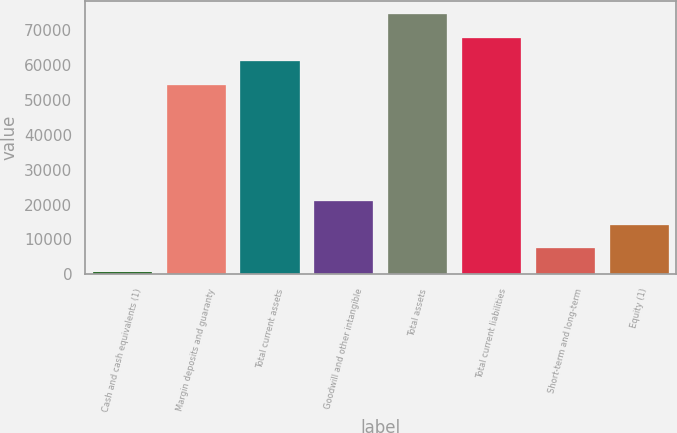Convert chart to OTSL. <chart><loc_0><loc_0><loc_500><loc_500><bar_chart><fcel>Cash and cash equivalents (1)<fcel>Margin deposits and guaranty<fcel>Total current assets<fcel>Goodwill and other intangible<fcel>Total assets<fcel>Total current liabilities<fcel>Short-term and long-term<fcel>Equity (1)<nl><fcel>652<fcel>54218.2<fcel>60978.4<fcel>20932.6<fcel>74498.8<fcel>67738.6<fcel>7412.2<fcel>14172.4<nl></chart> 